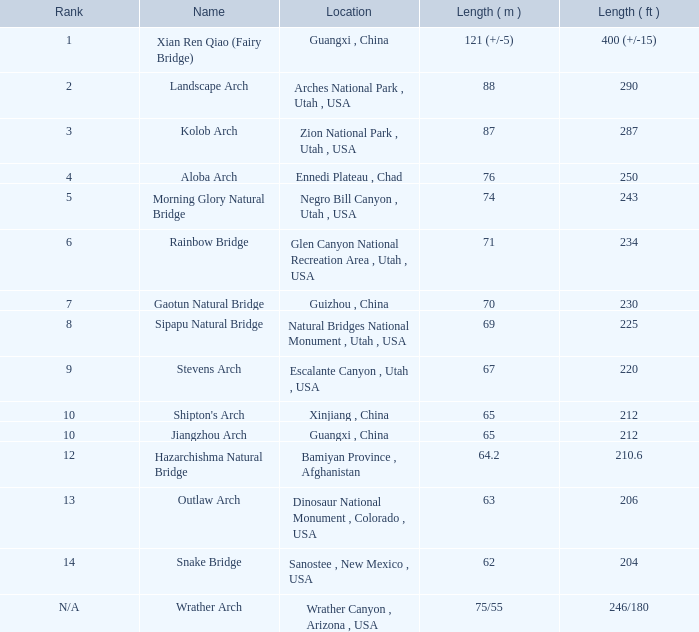2-meter-long arch with the greatest length located? Bamiyan Province , Afghanistan. 